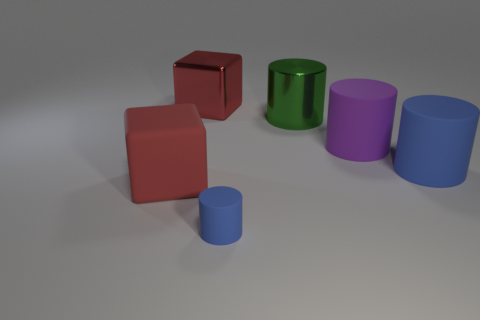Subtract all green shiny cylinders. How many cylinders are left? 3 Subtract all green cylinders. How many cylinders are left? 3 Add 3 big red metallic blocks. How many objects exist? 9 Subtract all cylinders. How many objects are left? 2 Subtract 0 gray cubes. How many objects are left? 6 Subtract all brown shiny spheres. Subtract all large green cylinders. How many objects are left? 5 Add 1 blocks. How many blocks are left? 3 Add 1 purple matte cubes. How many purple matte cubes exist? 1 